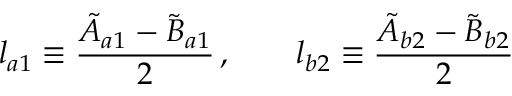Convert formula to latex. <formula><loc_0><loc_0><loc_500><loc_500>l _ { a 1 } \equiv \frac { \tilde { A } _ { a 1 } - \tilde { B } _ { a 1 } } { 2 } \, , \quad l _ { b 2 } \equiv \frac { \tilde { A } _ { b 2 } - \tilde { B } _ { b 2 } } { 2 }</formula> 